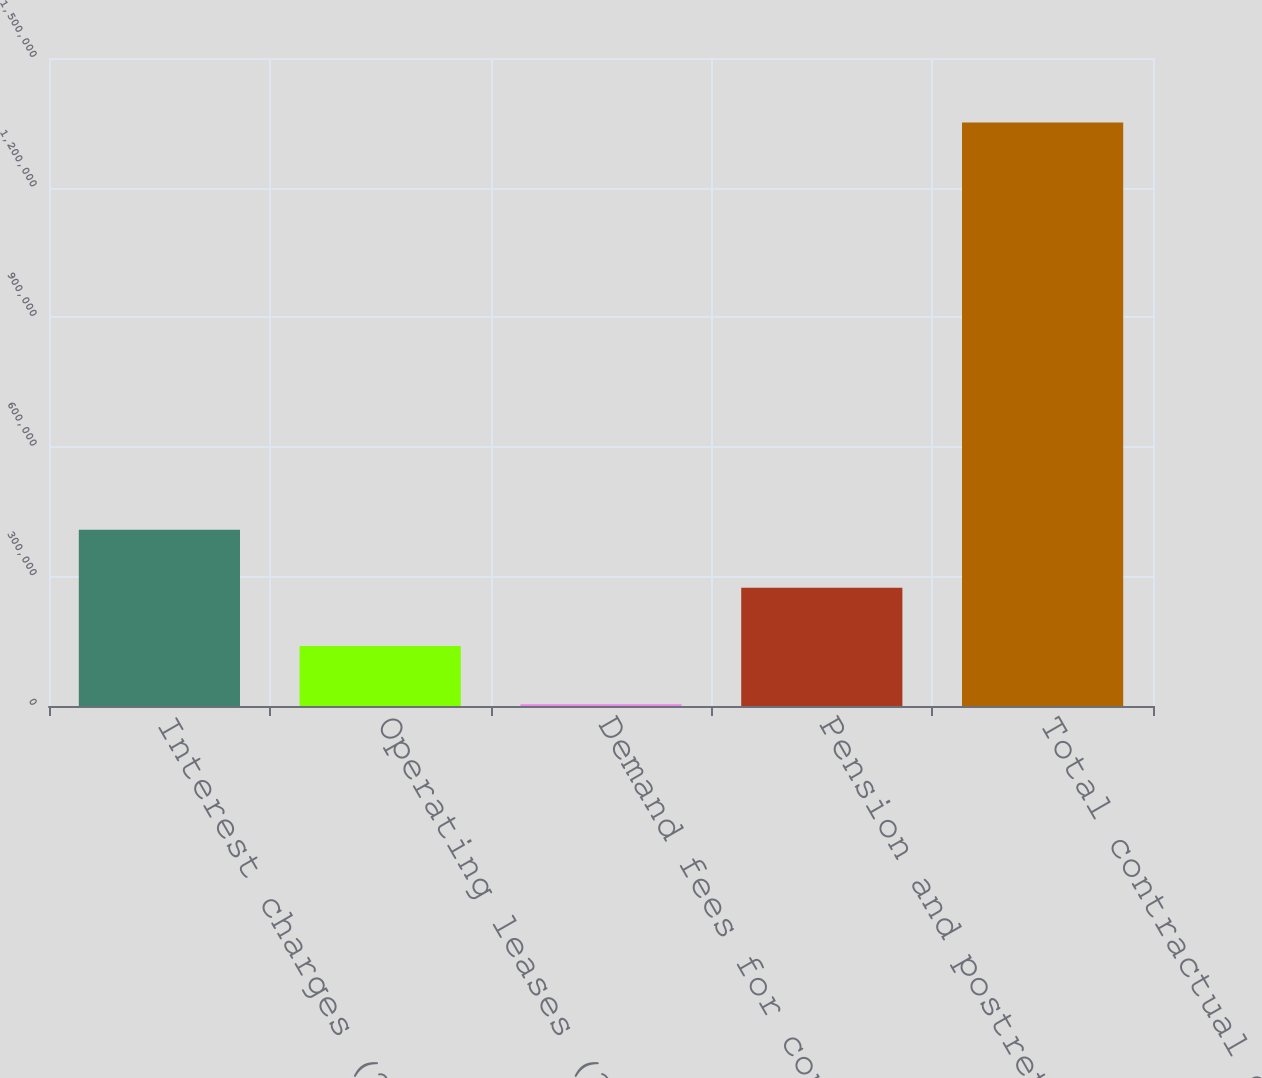Convert chart. <chart><loc_0><loc_0><loc_500><loc_500><bar_chart><fcel>Interest charges (2)<fcel>Operating leases (3)<fcel>Demand fees for contracted<fcel>Pension and postretirement<fcel>Total contractual obligations<nl><fcel>408134<fcel>138845<fcel>4200<fcel>273490<fcel>1.35065e+06<nl></chart> 